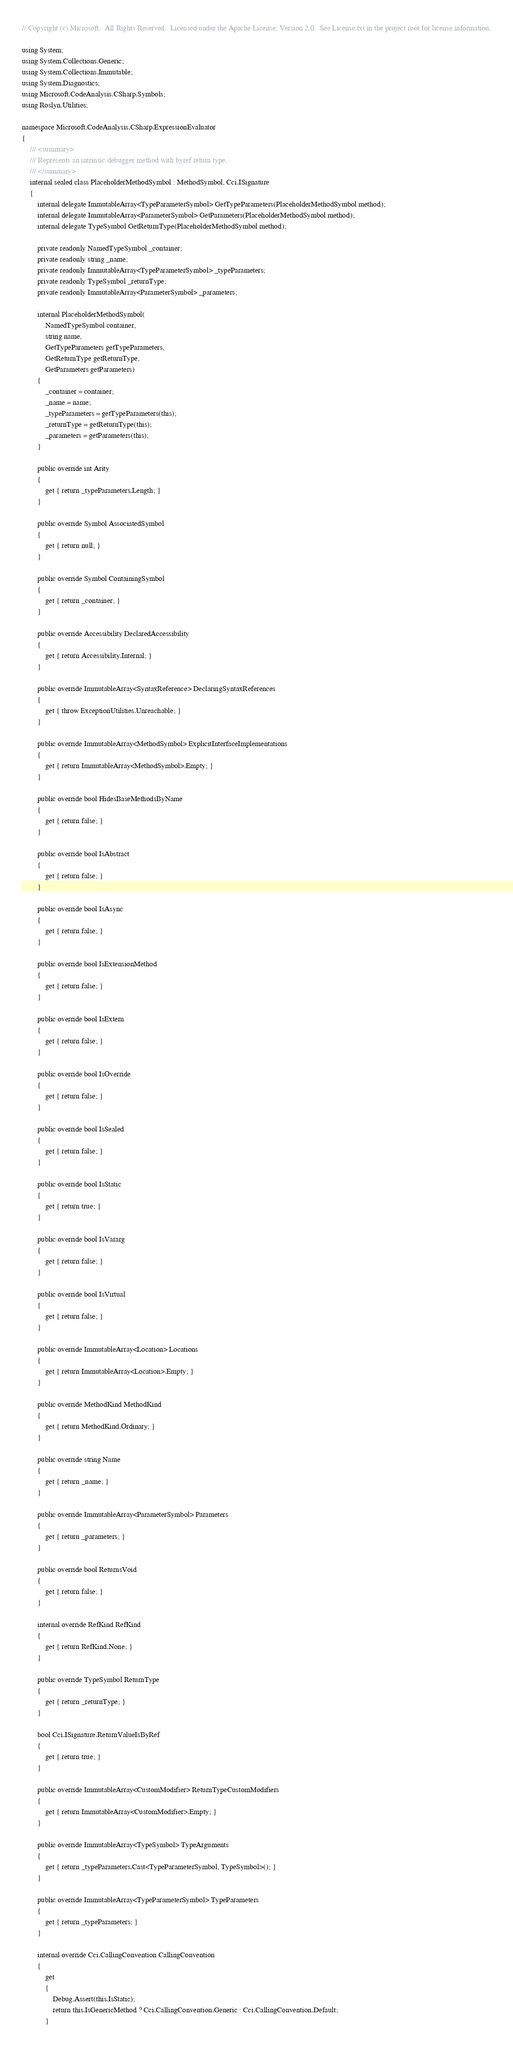<code> <loc_0><loc_0><loc_500><loc_500><_C#_>// Copyright (c) Microsoft.  All Rights Reserved.  Licensed under the Apache License, Version 2.0.  See License.txt in the project root for license information.

using System;
using System.Collections.Generic;
using System.Collections.Immutable;
using System.Diagnostics;
using Microsoft.CodeAnalysis.CSharp.Symbols;
using Roslyn.Utilities;

namespace Microsoft.CodeAnalysis.CSharp.ExpressionEvaluator
{
    /// <summary>
    /// Represents an intrinsic debugger method with byref return type.
    /// </summary>
    internal sealed class PlaceholderMethodSymbol : MethodSymbol, Cci.ISignature
    {
        internal delegate ImmutableArray<TypeParameterSymbol> GetTypeParameters(PlaceholderMethodSymbol method);
        internal delegate ImmutableArray<ParameterSymbol> GetParameters(PlaceholderMethodSymbol method);
        internal delegate TypeSymbol GetReturnType(PlaceholderMethodSymbol method);

        private readonly NamedTypeSymbol _container;
        private readonly string _name;
        private readonly ImmutableArray<TypeParameterSymbol> _typeParameters;
        private readonly TypeSymbol _returnType;
        private readonly ImmutableArray<ParameterSymbol> _parameters;

        internal PlaceholderMethodSymbol(
            NamedTypeSymbol container,
            string name,
            GetTypeParameters getTypeParameters,
            GetReturnType getReturnType,
            GetParameters getParameters)
        {
            _container = container;
            _name = name;
            _typeParameters = getTypeParameters(this);
            _returnType = getReturnType(this);
            _parameters = getParameters(this);
        }

        public override int Arity
        {
            get { return _typeParameters.Length; }
        }

        public override Symbol AssociatedSymbol
        {
            get { return null; }
        }

        public override Symbol ContainingSymbol
        {
            get { return _container; }
        }

        public override Accessibility DeclaredAccessibility
        {
            get { return Accessibility.Internal; }
        }

        public override ImmutableArray<SyntaxReference> DeclaringSyntaxReferences
        {
            get { throw ExceptionUtilities.Unreachable; }
        }

        public override ImmutableArray<MethodSymbol> ExplicitInterfaceImplementations
        {
            get { return ImmutableArray<MethodSymbol>.Empty; }
        }

        public override bool HidesBaseMethodsByName
        {
            get { return false; }
        }

        public override bool IsAbstract
        {
            get { return false; }
        }

        public override bool IsAsync
        {
            get { return false; }
        }

        public override bool IsExtensionMethod
        {
            get { return false; }
        }

        public override bool IsExtern
        {
            get { return false; }
        }

        public override bool IsOverride
        {
            get { return false; }
        }

        public override bool IsSealed
        {
            get { return false; }
        }

        public override bool IsStatic
        {
            get { return true; }
        }

        public override bool IsVararg
        {
            get { return false; }
        }

        public override bool IsVirtual
        {
            get { return false; }
        }

        public override ImmutableArray<Location> Locations
        {
            get { return ImmutableArray<Location>.Empty; }
        }

        public override MethodKind MethodKind
        {
            get { return MethodKind.Ordinary; }
        }

        public override string Name
        {
            get { return _name; }
        }

        public override ImmutableArray<ParameterSymbol> Parameters
        {
            get { return _parameters; }
        }

        public override bool ReturnsVoid
        {
            get { return false; }
        }

        internal override RefKind RefKind
        {
            get { return RefKind.None; }
        }

        public override TypeSymbol ReturnType
        {
            get { return _returnType; }
        }

        bool Cci.ISignature.ReturnValueIsByRef
        {
            get { return true; }
        }

        public override ImmutableArray<CustomModifier> ReturnTypeCustomModifiers
        {
            get { return ImmutableArray<CustomModifier>.Empty; }
        }

        public override ImmutableArray<TypeSymbol> TypeArguments
        {
            get { return _typeParameters.Cast<TypeParameterSymbol, TypeSymbol>(); }
        }

        public override ImmutableArray<TypeParameterSymbol> TypeParameters
        {
            get { return _typeParameters; }
        }

        internal override Cci.CallingConvention CallingConvention
        {
            get
            {
                Debug.Assert(this.IsStatic);
                return this.IsGenericMethod ? Cci.CallingConvention.Generic : Cci.CallingConvention.Default;
            }</code> 